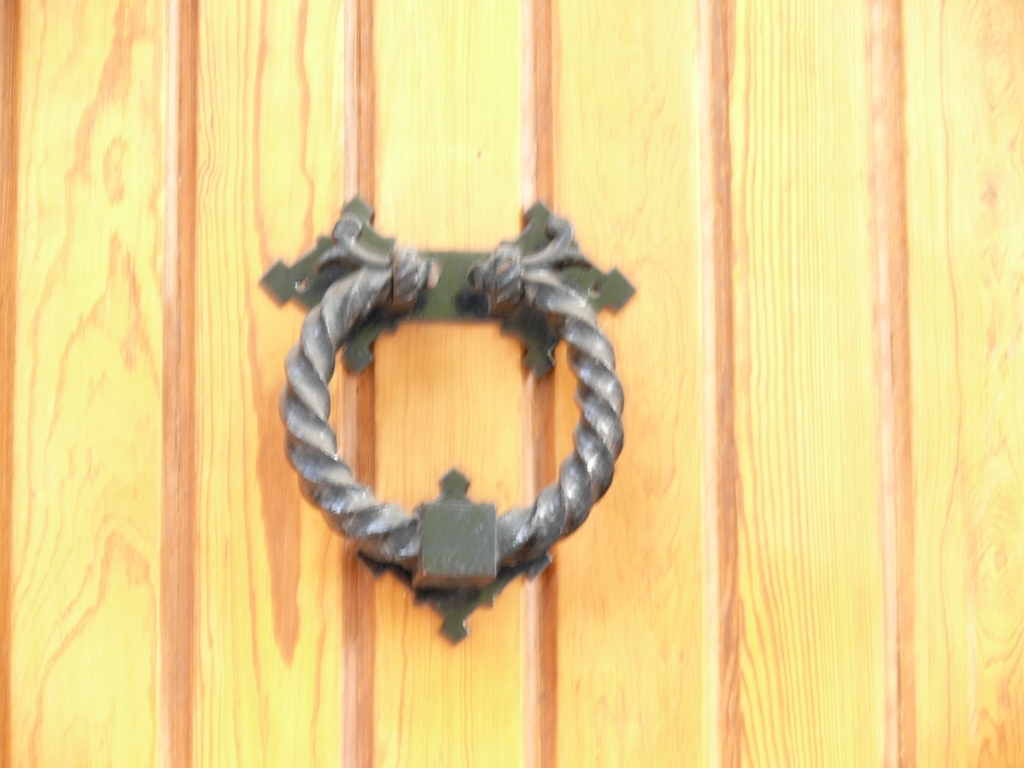Could you describe the material and color of this object? Certainly! The door knocker is made of what appears to be wrought iron, characterized by its slightly irregular texture and strength. It is primarily a dark gray color, with variations that suggest an aged patina which adds to its antique charm. 